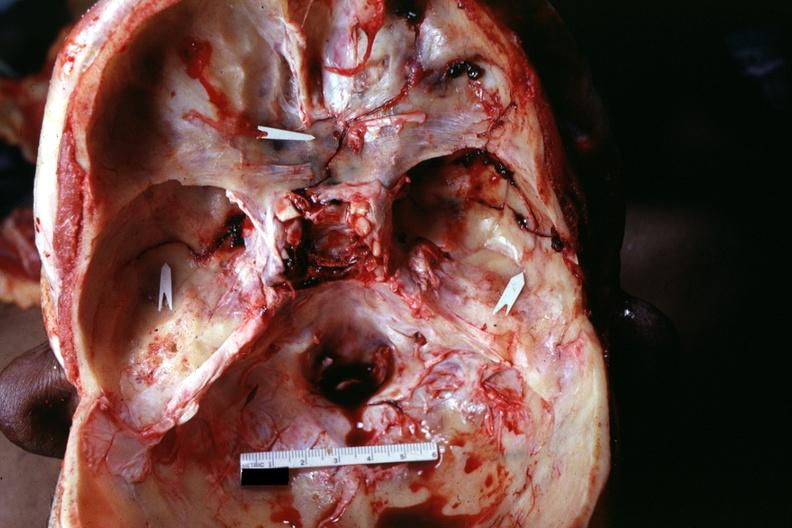s basilar skull fracture present?
Answer the question using a single word or phrase. Yes 